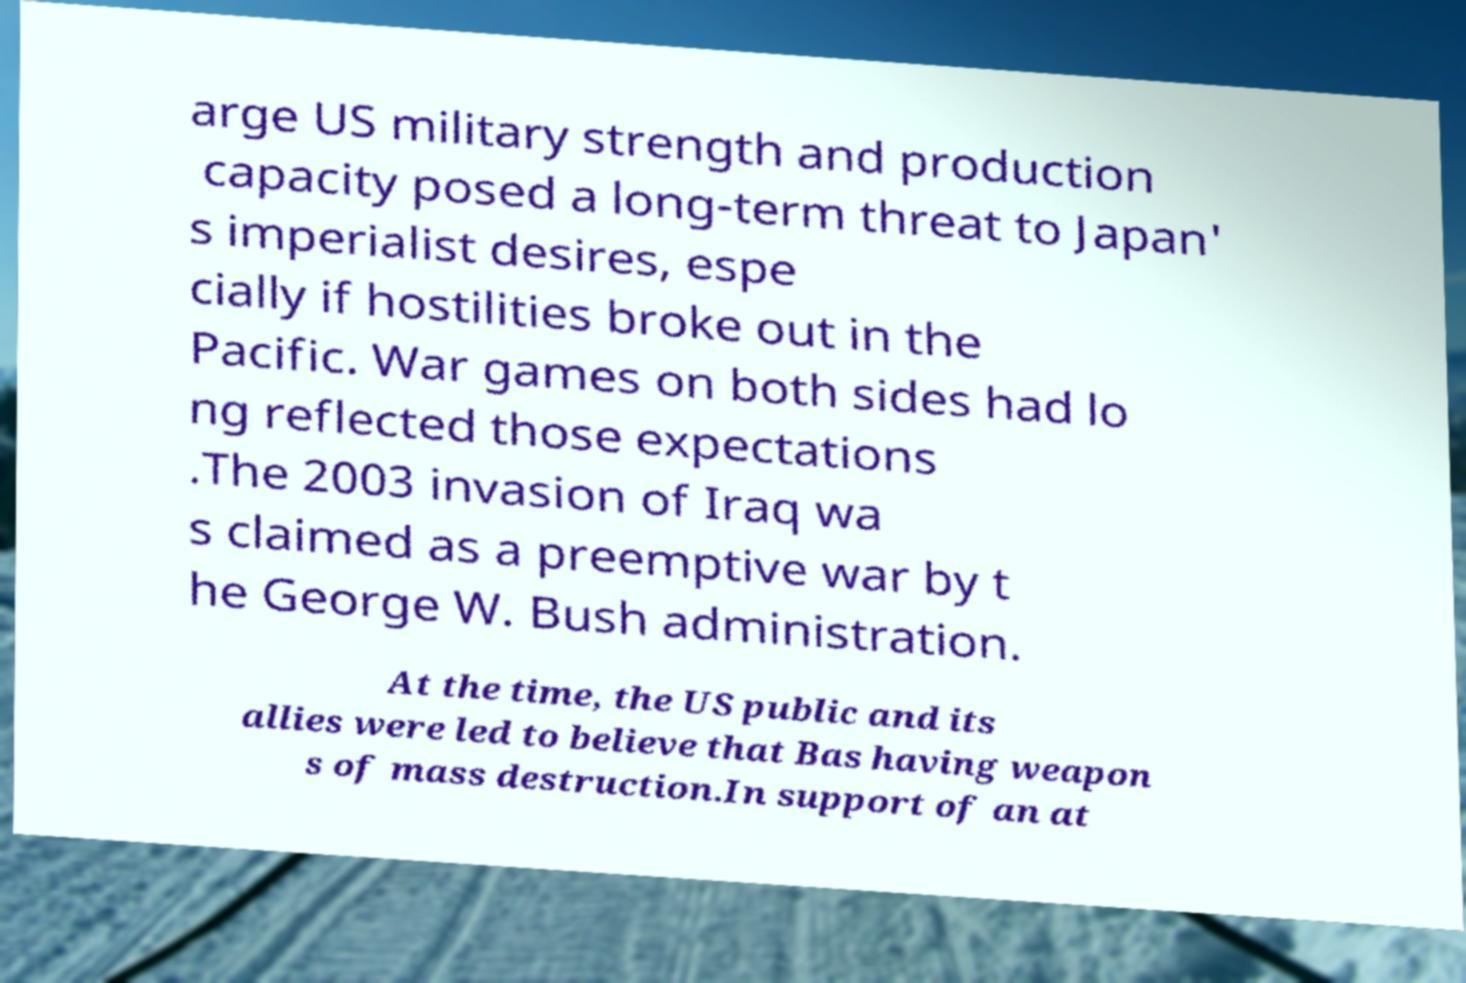There's text embedded in this image that I need extracted. Can you transcribe it verbatim? arge US military strength and production capacity posed a long-term threat to Japan' s imperialist desires, espe cially if hostilities broke out in the Pacific. War games on both sides had lo ng reflected those expectations .The 2003 invasion of Iraq wa s claimed as a preemptive war by t he George W. Bush administration. At the time, the US public and its allies were led to believe that Bas having weapon s of mass destruction.In support of an at 